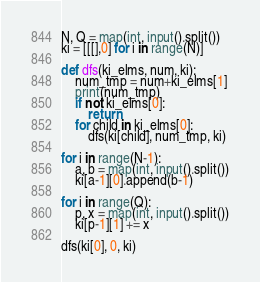Convert code to text. <code><loc_0><loc_0><loc_500><loc_500><_Python_>N, Q = map(int, input().split())
ki = [[[],0] for i in range(N)]

def dfs(ki_elms, num, ki):
    num_tmp = num+ki_elms[1]
    print(num_tmp)
    if not ki_elms[0]:
        return
    for child in ki_elms[0]:
        dfs(ki[child], num_tmp, ki)

for i in range(N-1):
    a, b = map(int, input().split())
    ki[a-1][0].append(b-1)

for i in range(Q):
    p, x = map(int, input().split())
    ki[p-1][1] += x

dfs(ki[0], 0, ki)</code> 